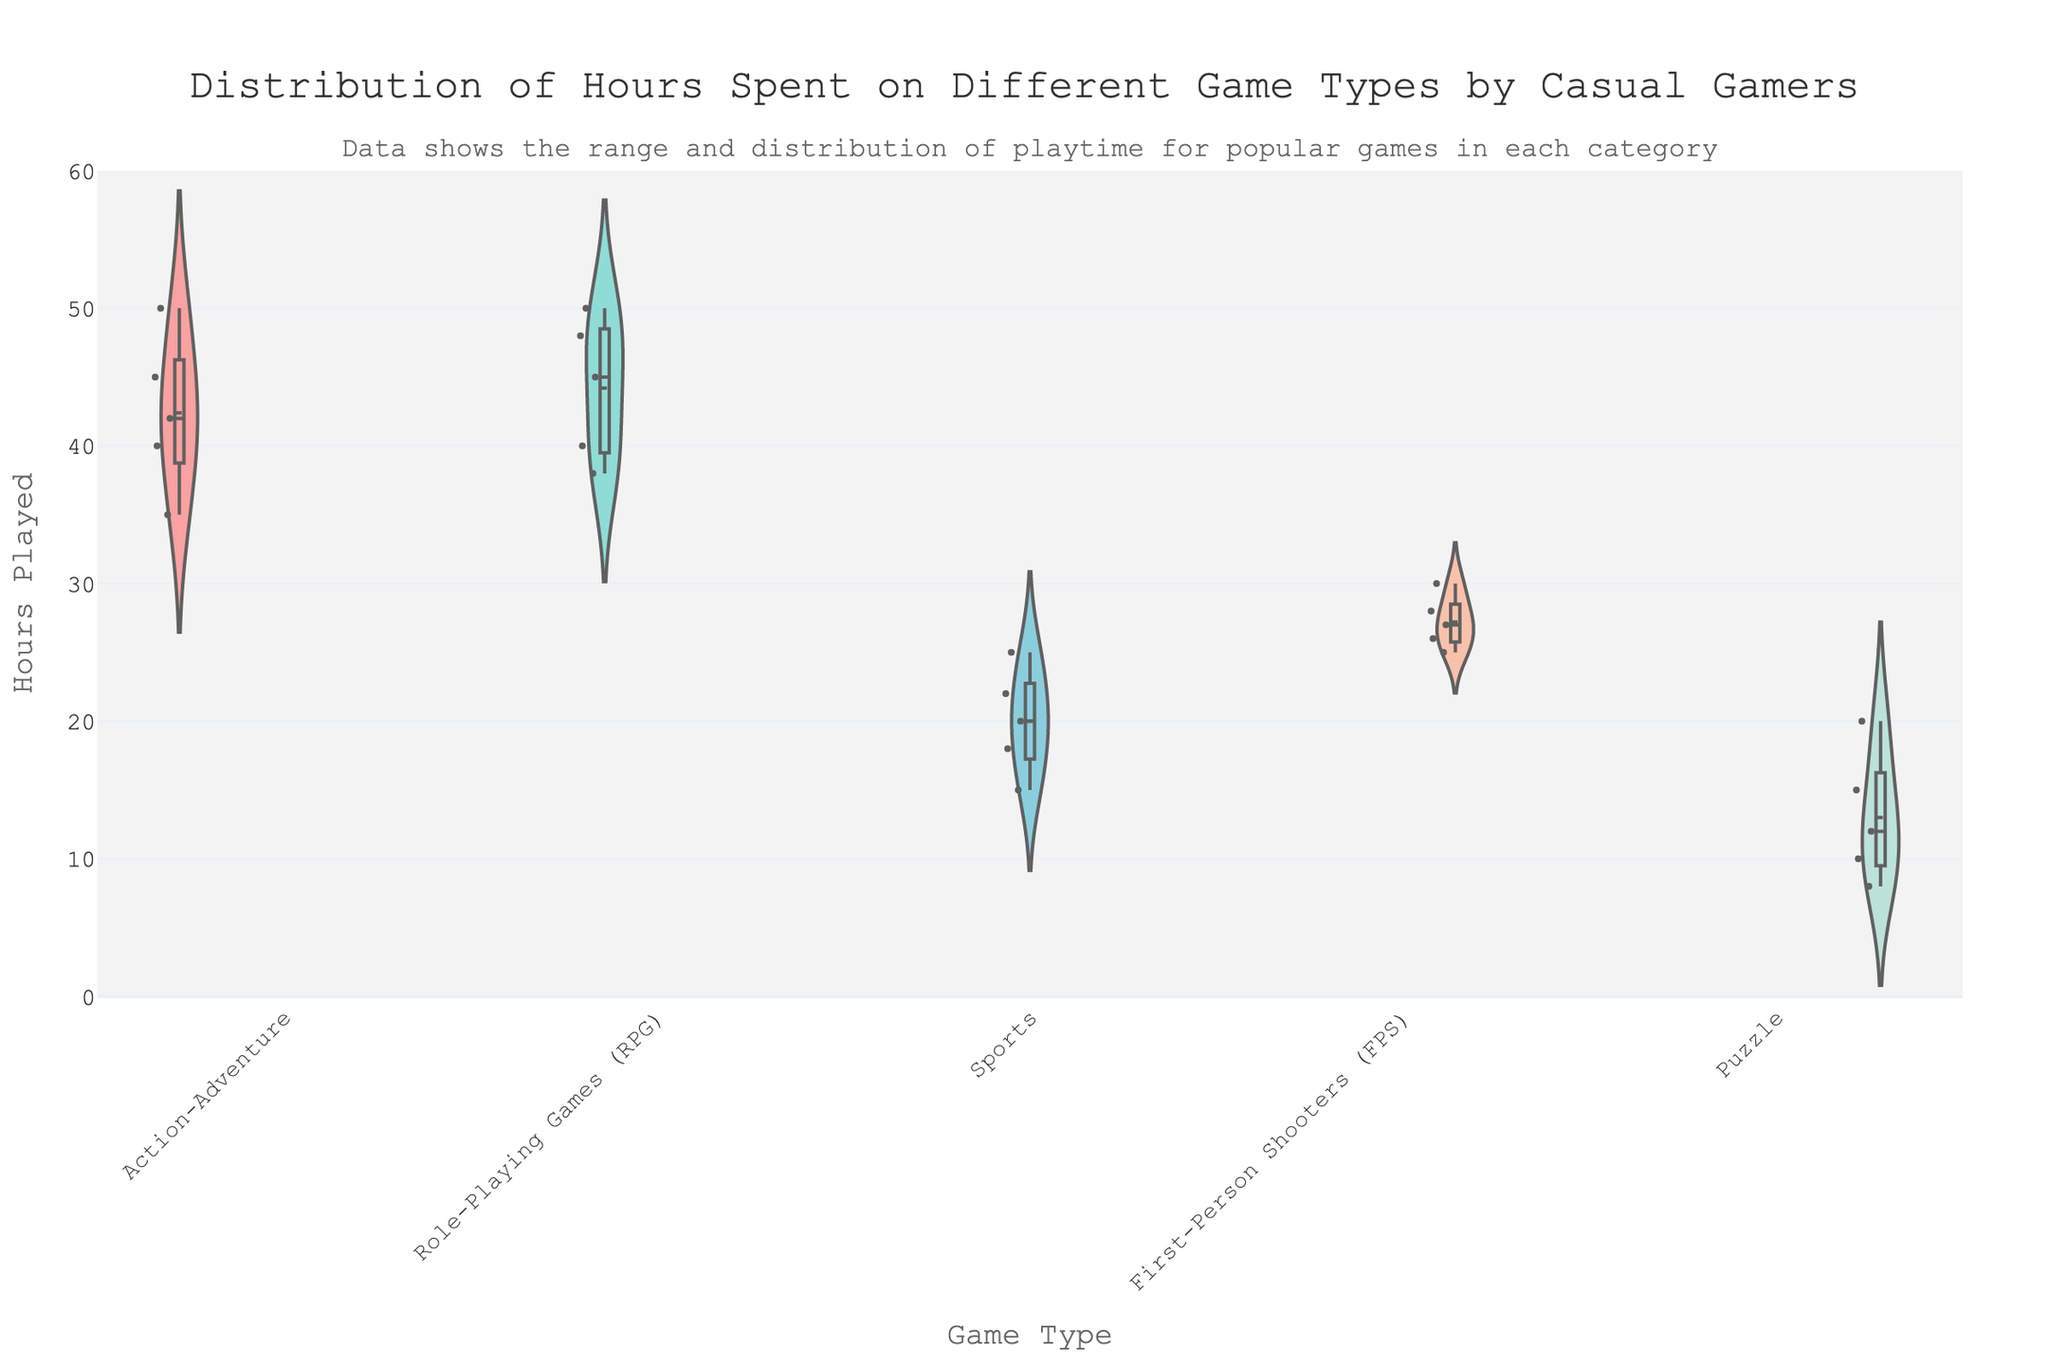How many game types are represented in the chart? To find the number of game types, look at the unique labels on the x-axis which represent each game type
Answer: 5 What is the title of the violin plot? The title is usually positioned at the top center of the plot and highlights the main focus of the visualization
Answer: "Distribution of Hours Spent on Different Game Types by Casual Gamers" Which game type has the widest range of hours played? By examining the vertical spread of the violin plots, the game type with the largest vertical spread indicates the widest range
Answer: Action-Adventure What is the average playtime for Puzzle games? Look at the position of the mean line within the violin plot for Puzzle games. Estimate the average by observing where this line is located on the y-axis
Answer: 13 Which game type has the most games played for over 40 hours? Identify which violin plot has more data points extending above the 40-hour mark on the y-axis
Answer: Action-Adventure and RPGs What is the median playtime for RPGs? Find the central horizontal line in the RPGs violin plot which represents the median and estimate its y-axis value
Answer: 45 How does the distribution of hours played for Sports games compare to FPS games? Compare the spread and the central tendencies (median and mean lines) of the FPS and Sports violin plots. Notice how concentrated the data points are and their ranges
Answer: Sports has a more concentrated distribution around 15-25 hours, while FPS shows a wider distribution around 25-30 hours Which game type has the smallest interquartile range (IQR) for hours played? The IQR can be visually approximated by the central part of the violin plot where it appears denser. The smallest IQR will have the most compact central section
Answer: Sports Where does the mean playtime for Action-Adventure games lie? Locate the mean line within the Action-Adventure violin plot and estimate its position on the y-axis
Answer: Around 42 hours What can you infer about the playtime distribution for Puzzle games? Observing the shape and the spread of the violin plot for Puzzle games can help infer how hours are distributed. Notice if it’s more concentrated or spread out
Answer: The distribution is bimodal with concentrations around 10-12 hours and 18-20 hours 